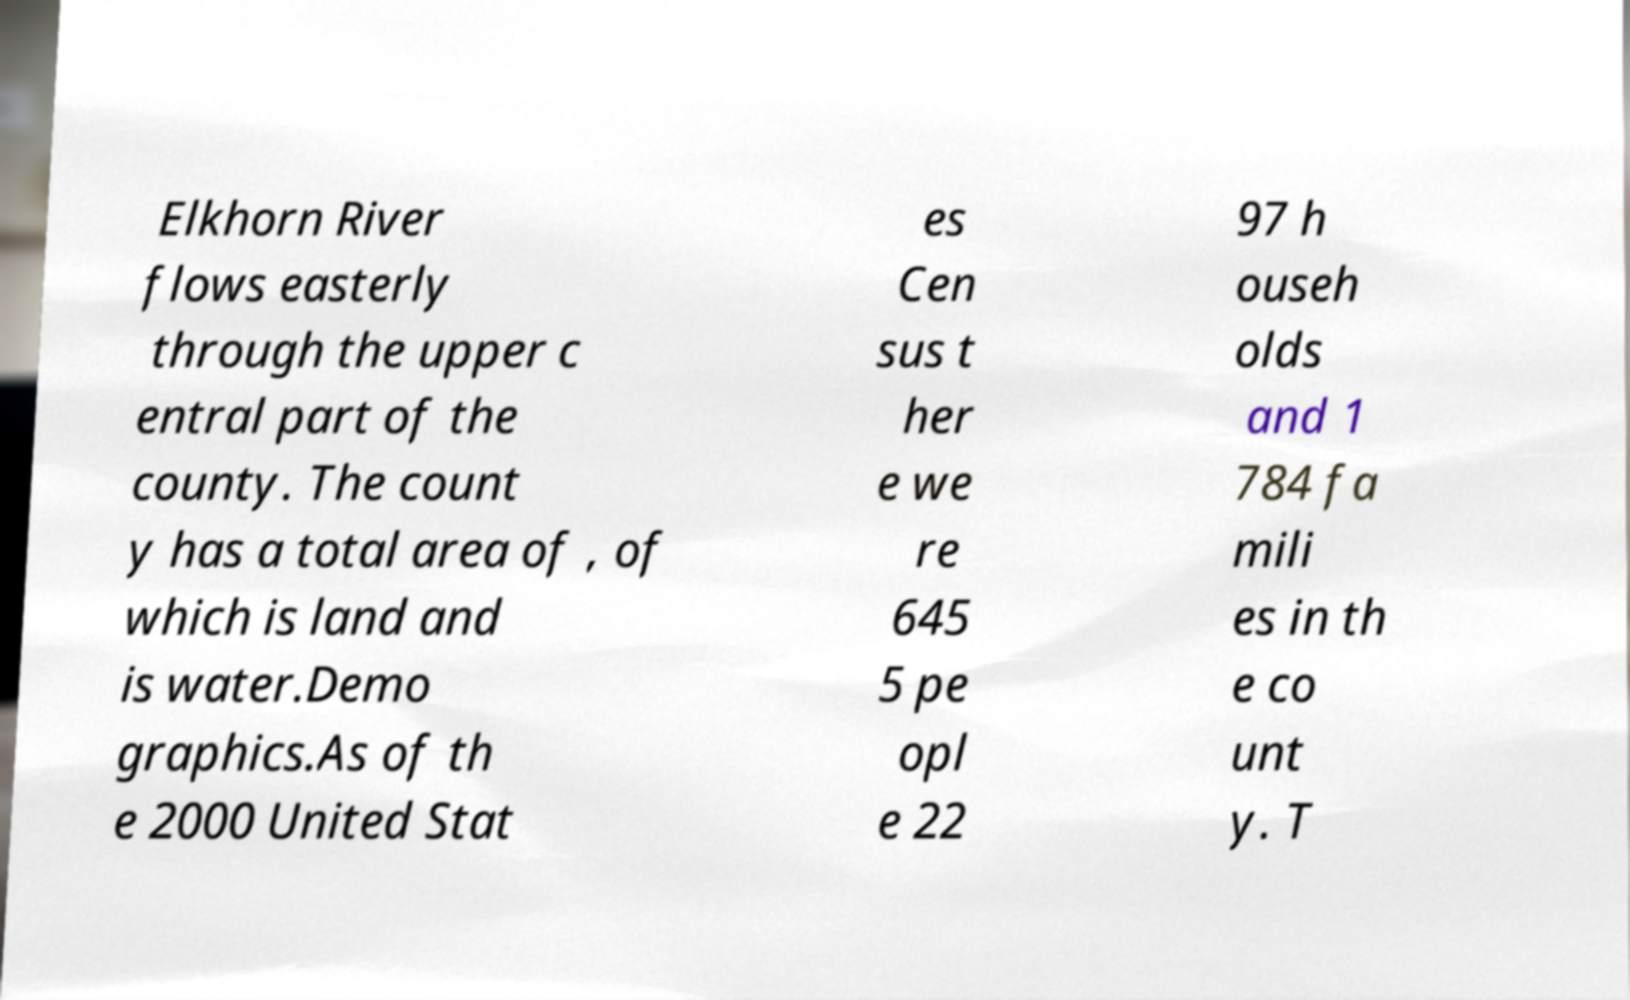Can you accurately transcribe the text from the provided image for me? Elkhorn River flows easterly through the upper c entral part of the county. The count y has a total area of , of which is land and is water.Demo graphics.As of th e 2000 United Stat es Cen sus t her e we re 645 5 pe opl e 22 97 h ouseh olds and 1 784 fa mili es in th e co unt y. T 